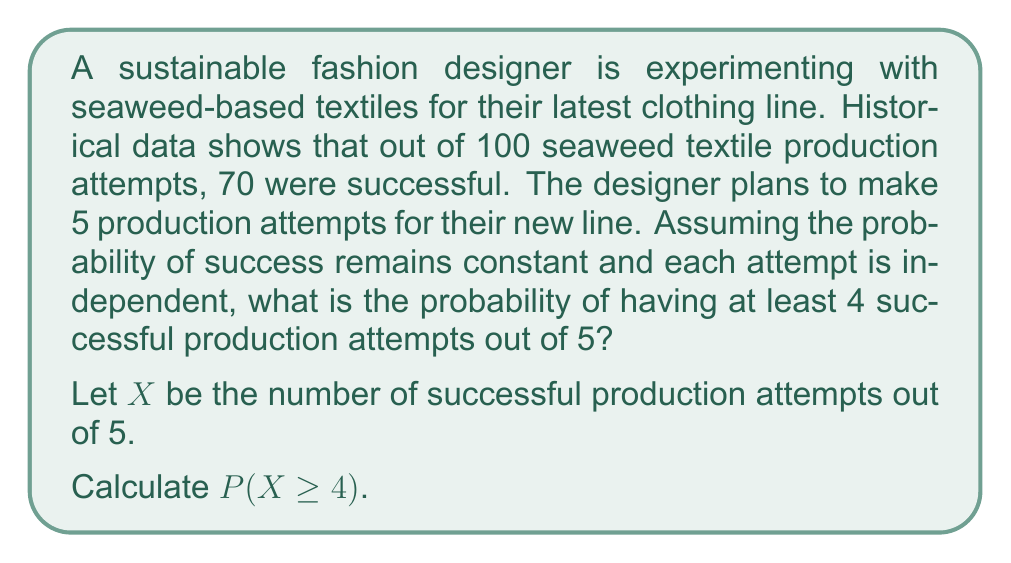What is the answer to this math problem? To solve this problem, we'll use the Binomial distribution and the concept of cumulative probability.

Step 1: Identify the parameters
- Number of trials: $n = 5$
- Probability of success: $p = 70/100 = 0.7$
- Probability of failure: $q = 1 - p = 0.3$

Step 2: Calculate $P(X \geq 4)$
This is equivalent to $P(X = 4) + P(X = 5)$

Step 3: Use the Binomial probability formula
$$P(X = k) = \binom{n}{k} p^k q^{n-k}$$

For $X = 4$:
$$P(X = 4) = \binom{5}{4} (0.7)^4 (0.3)^1 = 5 \cdot 0.7^4 \cdot 0.3 = 0.36015$$

For $X = 5$:
$$P(X = 5) = \binom{5}{5} (0.7)^5 (0.3)^0 = 1 \cdot 0.7^5 = 0.16807$$

Step 4: Sum the probabilities
$$P(X \geq 4) = P(X = 4) + P(X = 5) = 0.36015 + 0.16807 = 0.52822$$

Therefore, the probability of having at least 4 successful production attempts out of 5 is approximately 0.52822 or 52.822%.
Answer: 0.52822 